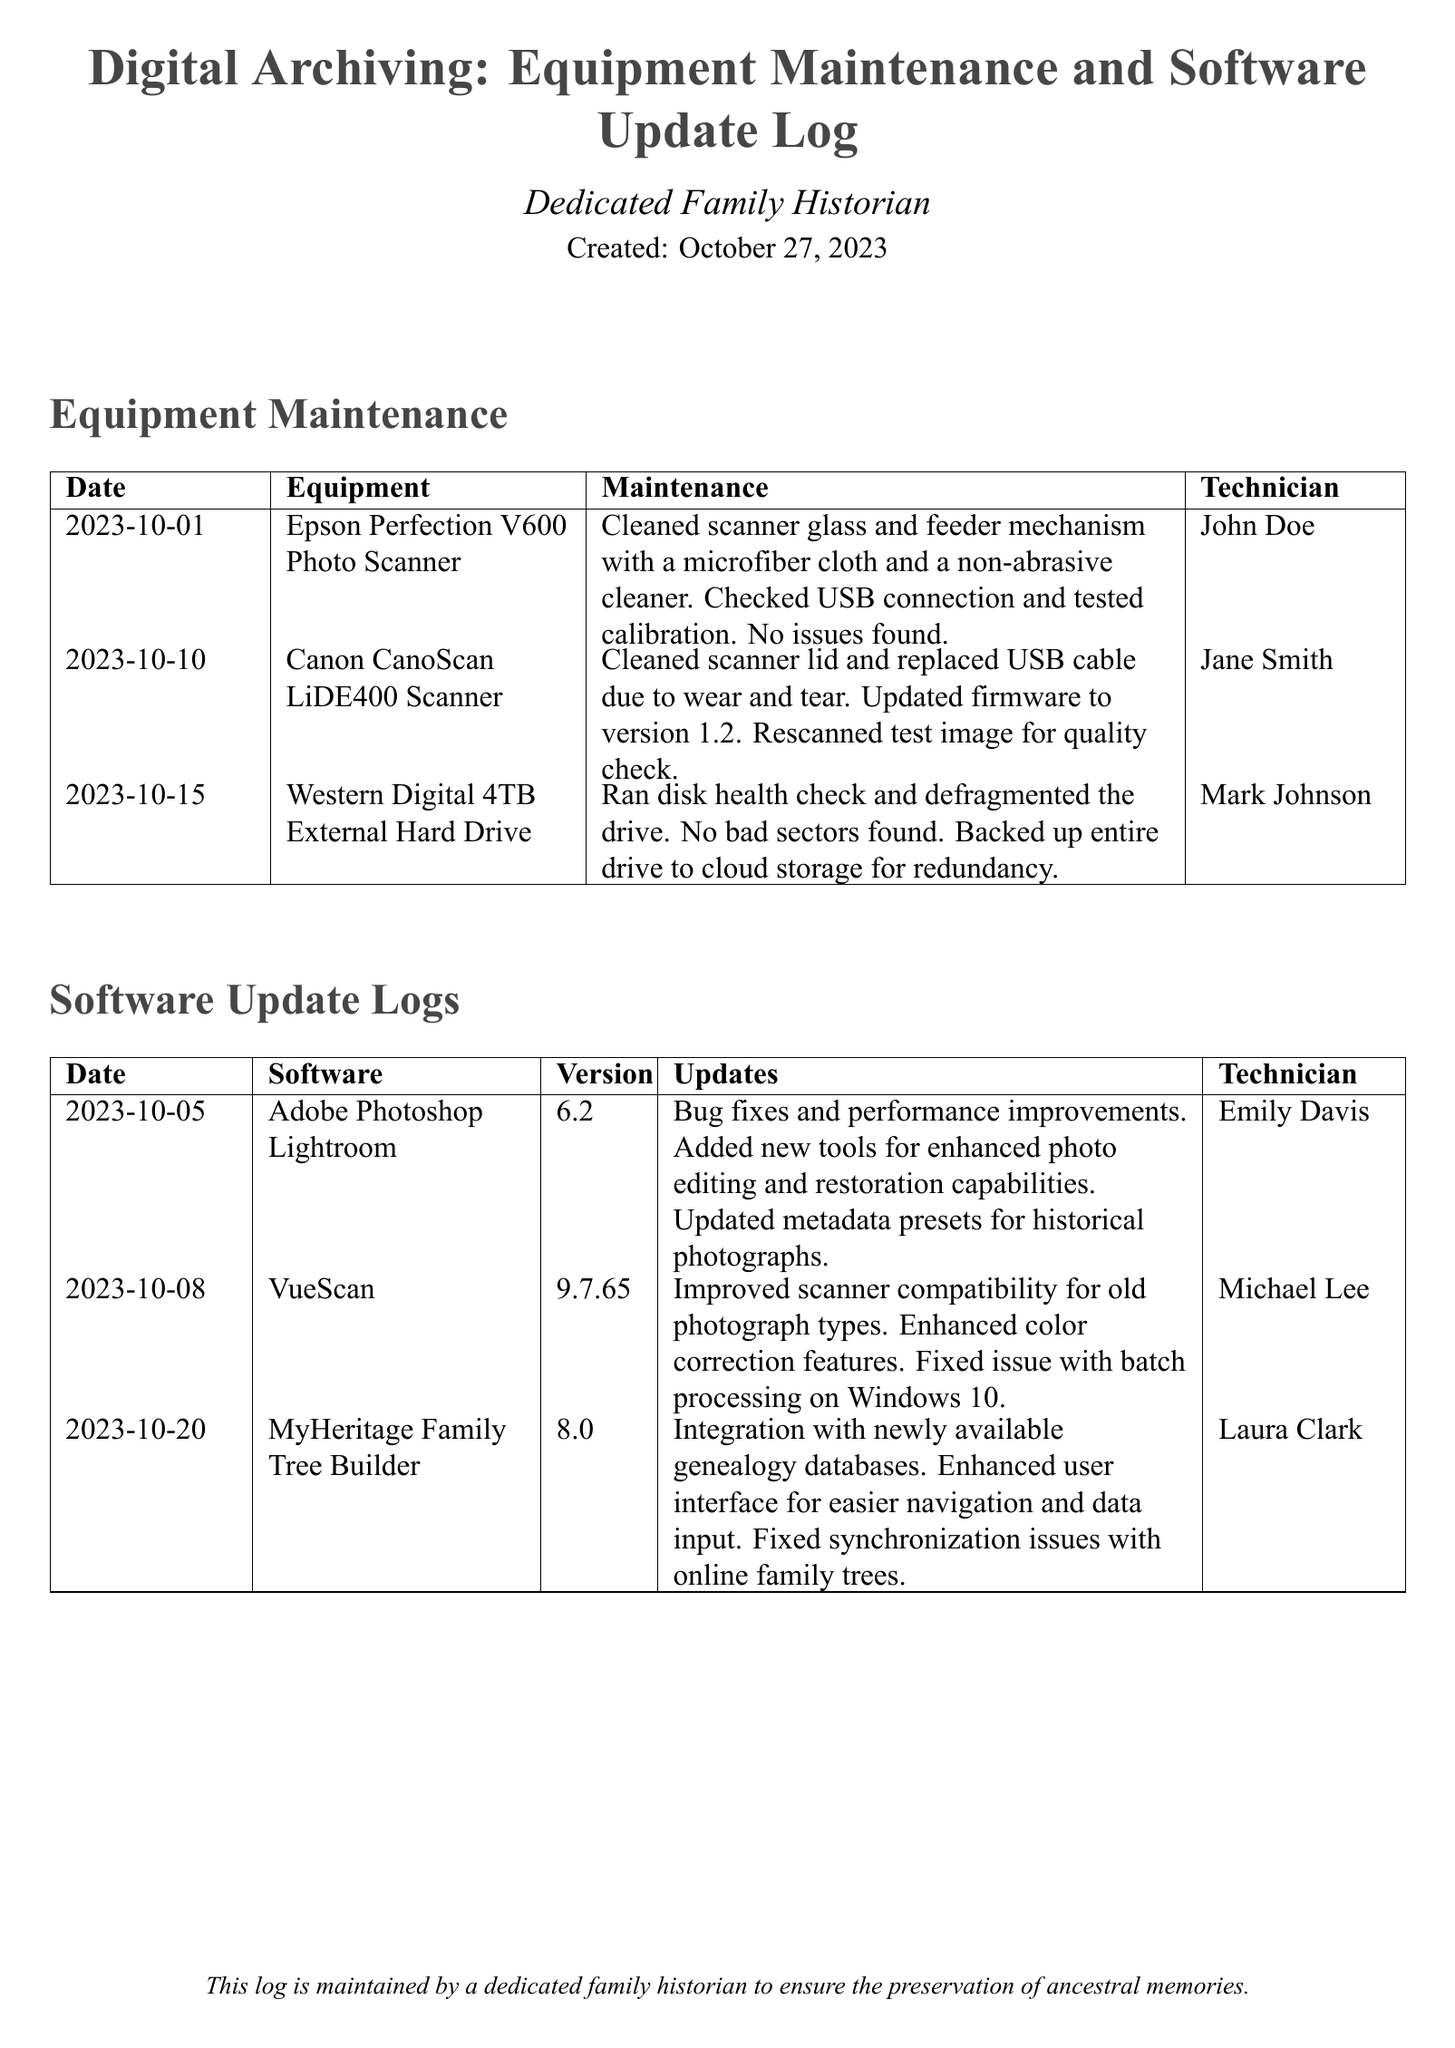What is the date of the first equipment maintenance entry? The first equipment maintenance entry is dated October 1, 2023.
Answer: October 1, 2023 Who performed the maintenance on the Canon CanoScan LiDE400 Scanner? The maintenance on the Canon CanoScan LiDE400 Scanner was performed by Jane Smith.
Answer: Jane Smith What software was updated on October 8, 2023? The software updated on October 8, 2023, was VueScan.
Answer: VueScan How many external hard drives are mentioned in the equipment maintenance log? There is one external hard drive mentioned in the equipment maintenance log.
Answer: One What version of Adobe Photoshop Lightroom was updated? The updated version of Adobe Photoshop Lightroom is 6.2.
Answer: 6.2 What type of technician performed the first maintenance on the scanner? The first maintenance on the scanner was performed by John Doe, a technician.
Answer: John Doe What was the purpose of the update on October 20, 2023, for MyHeritage Family Tree Builder? The purpose of the update was integration with newly available genealogy databases.
Answer: Integration with newly available genealogy databases Which technician handled the disk health check for the external hard drive? The disk health check for the external hard drive was handled by Mark Johnson.
Answer: Mark Johnson What feature was improved in VueScan's update? The feature improved in VueScan's update was scanner compatibility for old photograph types.
Answer: Scanner compatibility for old photograph types 